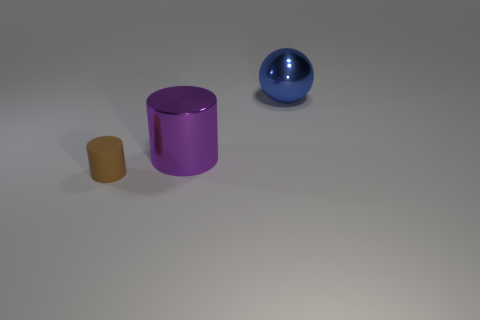Is the material of the big object left of the large blue object the same as the big ball?
Offer a terse response. Yes. What shape is the large metal thing to the left of the large blue metallic object?
Make the answer very short. Cylinder. What number of purple metallic cylinders are the same size as the brown cylinder?
Provide a succinct answer. 0. How big is the purple shiny cylinder?
Offer a very short reply. Large. How many small objects are to the right of the big blue metallic sphere?
Offer a very short reply. 0. There is another thing that is the same material as the purple thing; what shape is it?
Make the answer very short. Sphere. Is the number of brown objects that are left of the small brown matte object less than the number of tiny matte objects right of the big shiny cylinder?
Offer a terse response. No. Are there more big brown metal cubes than purple cylinders?
Ensure brevity in your answer.  No. What is the blue thing made of?
Your response must be concise. Metal. What is the color of the large thing that is behind the big purple shiny cylinder?
Your answer should be compact. Blue. 